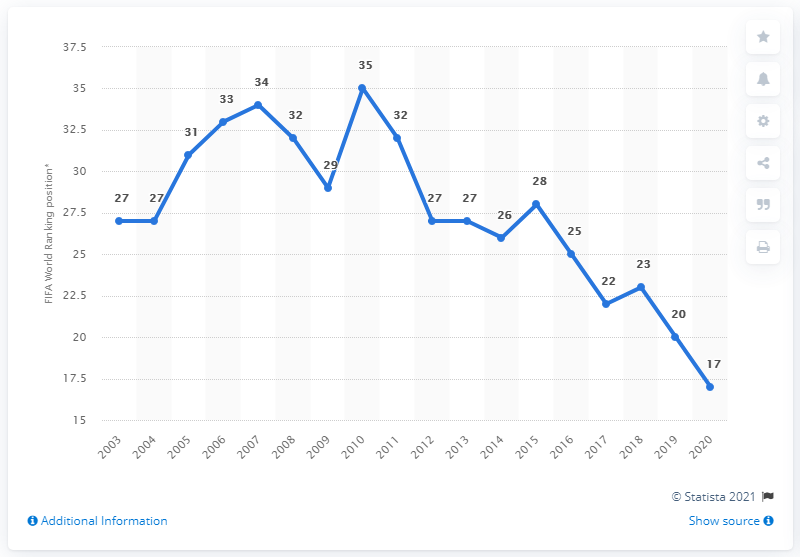Indicate a few pertinent items in this graphic. In 2010, Belgium's women's football team reached the lowest ranking on the FIFA World Ranking. In 2010, the women's football team of Belgium ranked 35th out of all the teams participating in the competition. 